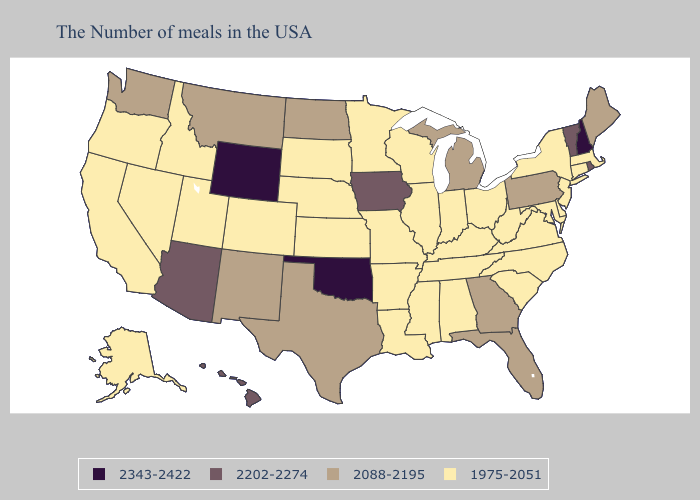Does New Jersey have the highest value in the Northeast?
Quick response, please. No. What is the lowest value in the West?
Keep it brief. 1975-2051. Which states have the lowest value in the USA?
Answer briefly. Massachusetts, Connecticut, New York, New Jersey, Delaware, Maryland, Virginia, North Carolina, South Carolina, West Virginia, Ohio, Kentucky, Indiana, Alabama, Tennessee, Wisconsin, Illinois, Mississippi, Louisiana, Missouri, Arkansas, Minnesota, Kansas, Nebraska, South Dakota, Colorado, Utah, Idaho, Nevada, California, Oregon, Alaska. Name the states that have a value in the range 2088-2195?
Quick response, please. Maine, Pennsylvania, Florida, Georgia, Michigan, Texas, North Dakota, New Mexico, Montana, Washington. Among the states that border Maryland , which have the highest value?
Write a very short answer. Pennsylvania. What is the value of Ohio?
Write a very short answer. 1975-2051. Name the states that have a value in the range 2088-2195?
Give a very brief answer. Maine, Pennsylvania, Florida, Georgia, Michigan, Texas, North Dakota, New Mexico, Montana, Washington. Name the states that have a value in the range 2343-2422?
Keep it brief. New Hampshire, Oklahoma, Wyoming. What is the lowest value in the USA?
Give a very brief answer. 1975-2051. What is the value of Pennsylvania?
Short answer required. 2088-2195. Does the map have missing data?
Short answer required. No. What is the value of New Jersey?
Be succinct. 1975-2051. What is the value of Montana?
Answer briefly. 2088-2195. What is the value of Ohio?
Keep it brief. 1975-2051. 